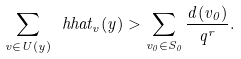<formula> <loc_0><loc_0><loc_500><loc_500>\sum _ { v \in U ( y ) } \ h h a t _ { v } ( y ) > \sum _ { v _ { 0 } \in S _ { 0 } } \frac { d ( v _ { 0 } ) } { q ^ { r } } .</formula> 